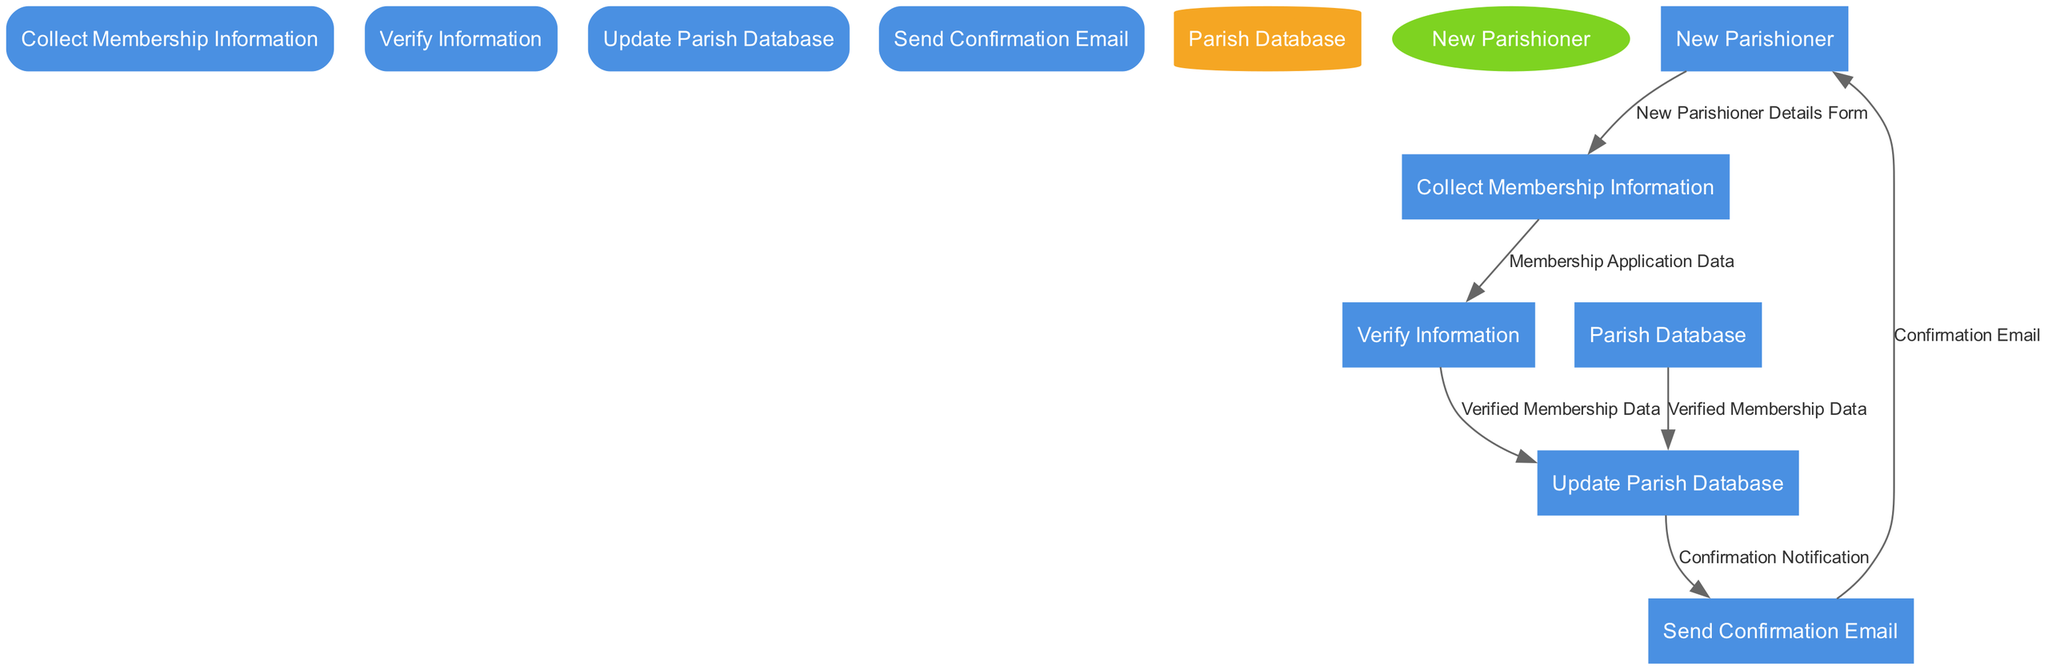What is the first process in the diagram? The first process is identified by the ID "1" and is located at the top of the process list in the diagram. It is titled "Collect Membership Information".
Answer: Collect Membership Information How many processes are represented in the diagram? The diagram shows a total of four processes. They are "Collect Membership Information", "Verify Information", "Update Parish Database", and "Send Confirmation Email".
Answer: Four What is the output of the "Verify Information" process? The "Verify Information" process produces two outputs: "Verified Membership Data" and "Verification Errors". Both outputs are shown connected to the process in the diagram.
Answer: Verified Membership Data, Verification Errors Which external entity is represented in the diagram? The diagram includes one external entity marked as "New Parishioner". It is displayed as an ellipse, indicating a user or stakeholder interaction.
Answer: New Parishioner What data flow connects "Collect Membership Information" to "Verify Information"? The flow that links "Collect Membership Information" to "Verify Information" is labeled "Membership Application Data". This indicates the data being passed to the next process.
Answer: Membership Application Data Which process sends the confirmation email? The "Send Confirmation Email" process is responsible for sending the confirmation email to the new parishioner as indicated in the diagram.
Answer: Send Confirmation Email How does the "Update Parish Database" process receive input? The "Update Parish Database" process receives input from the "Verify Information" process through the data flow labeled "Verified Membership Data". This highlights the dependency on the verified data.
Answer: Verified Membership Data What is stored in the "Parish Database"? The "Parish Database" stores all parishioner membership information, which is necessary for maintaining an updated and accurate record of new members.
Answer: All parishioner membership information What is the final output of the entire system in the diagram? The final output from the entire system is the "Confirmation Email" sent to the "New Parishioner", which is the last interaction in the flow.
Answer: Confirmation Email 